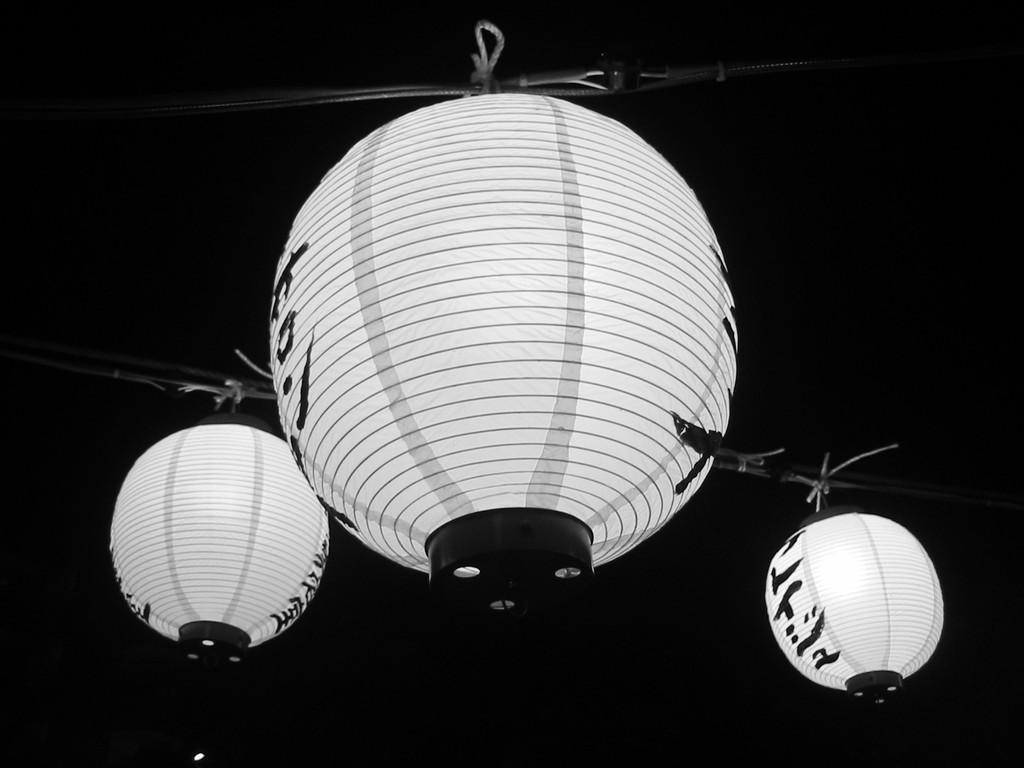Describe this image in one or two sentences. In this picture we can observe three spheres which were in white color. We can observe black color stripes on these three spheres. They were tied to the pole. The background is completely dark. 